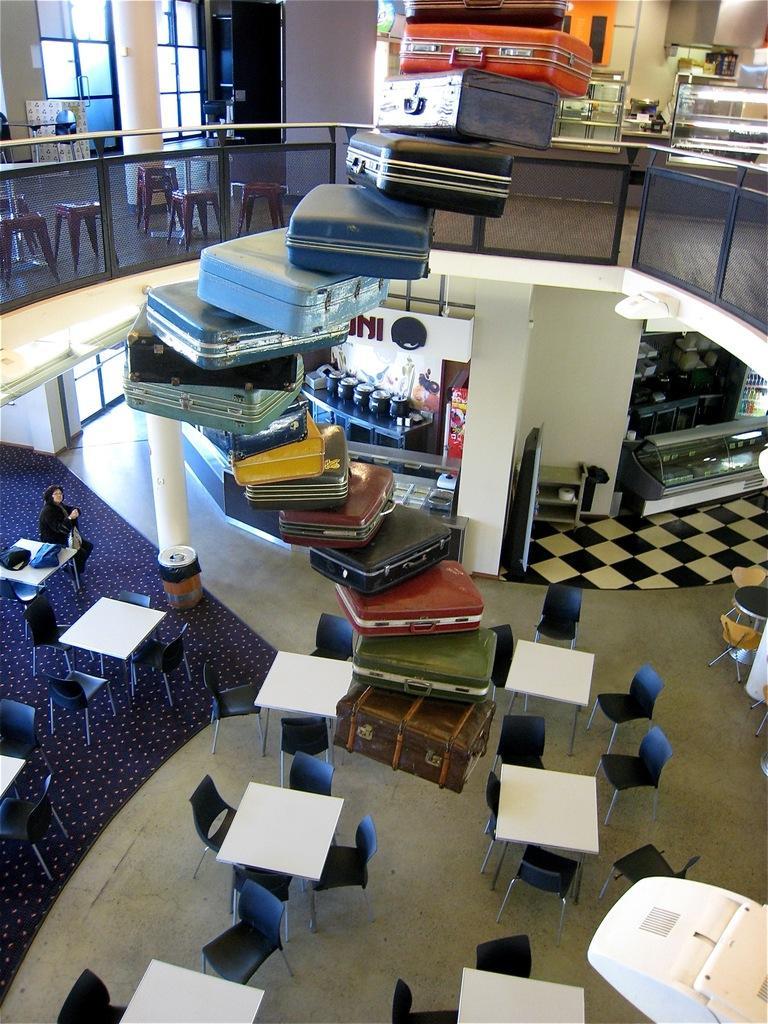Describe this image in one or two sentences. This picture seems to be like a food court area,there are many chairs and tables and in middle there are suit cases,this seems to be staircase. 